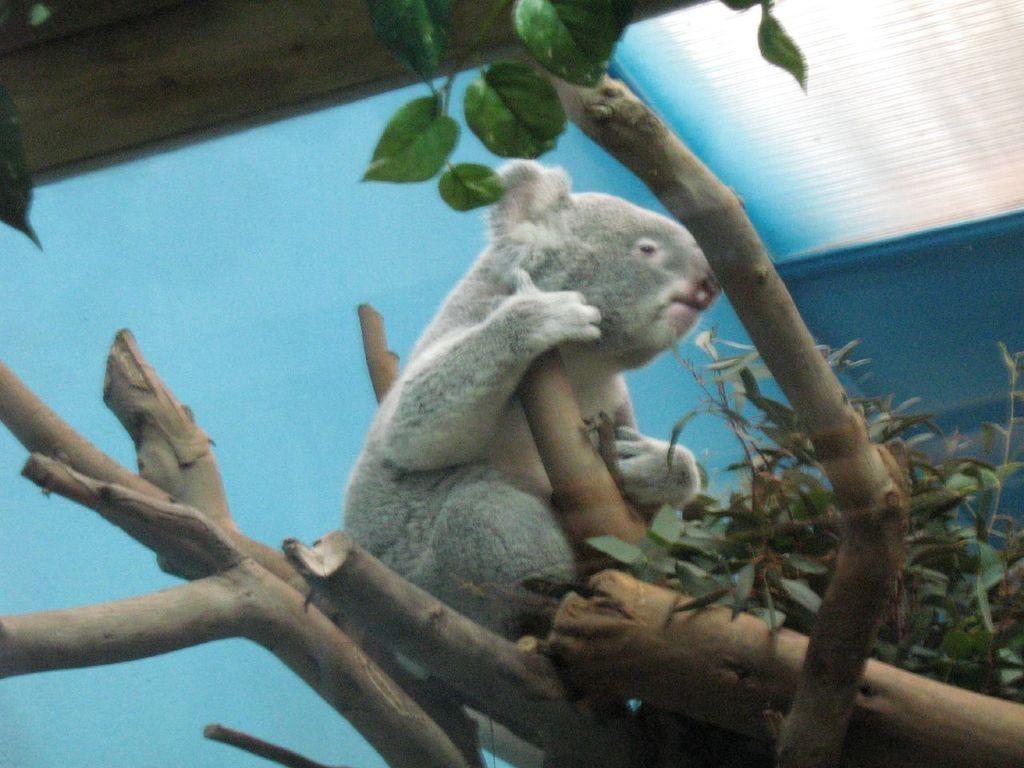Can you describe this image briefly? In this image we can see an animal sitting on a tree and we can see some leaves and we can see the background in blue color. 